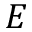<formula> <loc_0><loc_0><loc_500><loc_500>E</formula> 